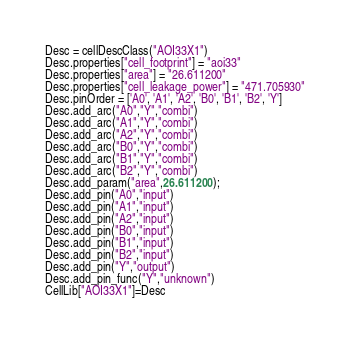<code> <loc_0><loc_0><loc_500><loc_500><_Python_>Desc = cellDescClass("AOI33X1")
Desc.properties["cell_footprint"] = "aoi33"
Desc.properties["area"] = "26.611200"
Desc.properties["cell_leakage_power"] = "471.705930"
Desc.pinOrder = ['A0', 'A1', 'A2', 'B0', 'B1', 'B2', 'Y']
Desc.add_arc("A0","Y","combi")
Desc.add_arc("A1","Y","combi")
Desc.add_arc("A2","Y","combi")
Desc.add_arc("B0","Y","combi")
Desc.add_arc("B1","Y","combi")
Desc.add_arc("B2","Y","combi")
Desc.add_param("area",26.611200);
Desc.add_pin("A0","input")
Desc.add_pin("A1","input")
Desc.add_pin("A2","input")
Desc.add_pin("B0","input")
Desc.add_pin("B1","input")
Desc.add_pin("B2","input")
Desc.add_pin("Y","output")
Desc.add_pin_func("Y","unknown")
CellLib["AOI33X1"]=Desc
</code> 